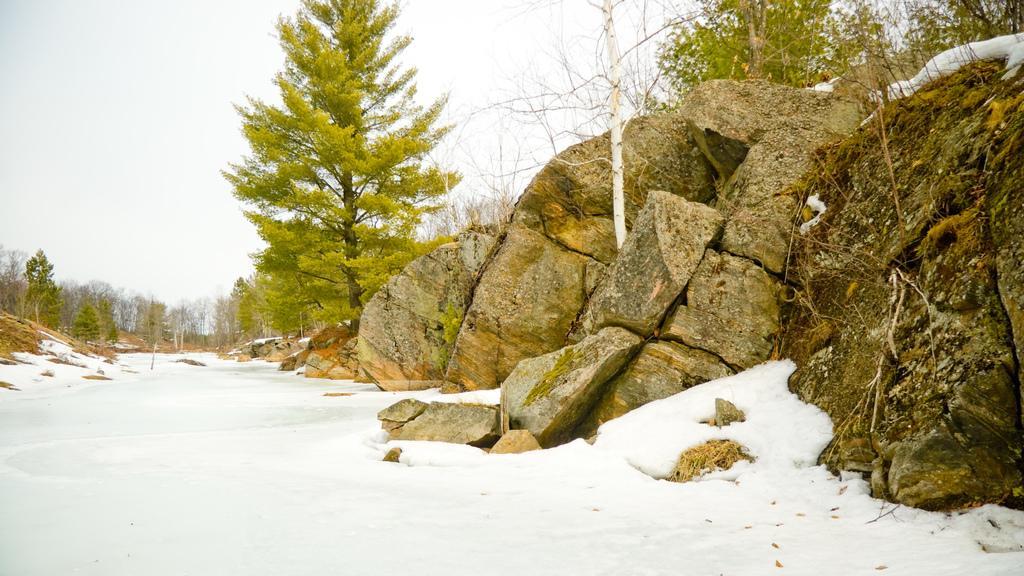Can you describe this image briefly? In this picture we can see the trees, rocks. At the bottom of the image we can see the snow. At the top of the image we can see the sky. 